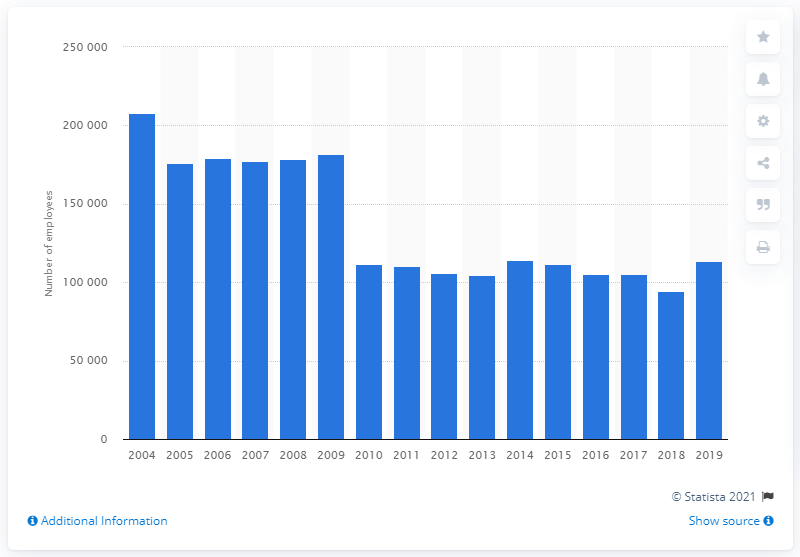Mention a couple of crucial points in this snapshot. In 2019, there were approximately 113,600 employees working for insurance companies in the United Kingdom. Approximately 111,611 employees were working at insurance companies in the UK in the year 2010. 